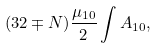Convert formula to latex. <formula><loc_0><loc_0><loc_500><loc_500>( 3 2 \mp N ) \frac { \mu _ { 1 0 } } { 2 } \int A _ { 1 0 } ,</formula> 